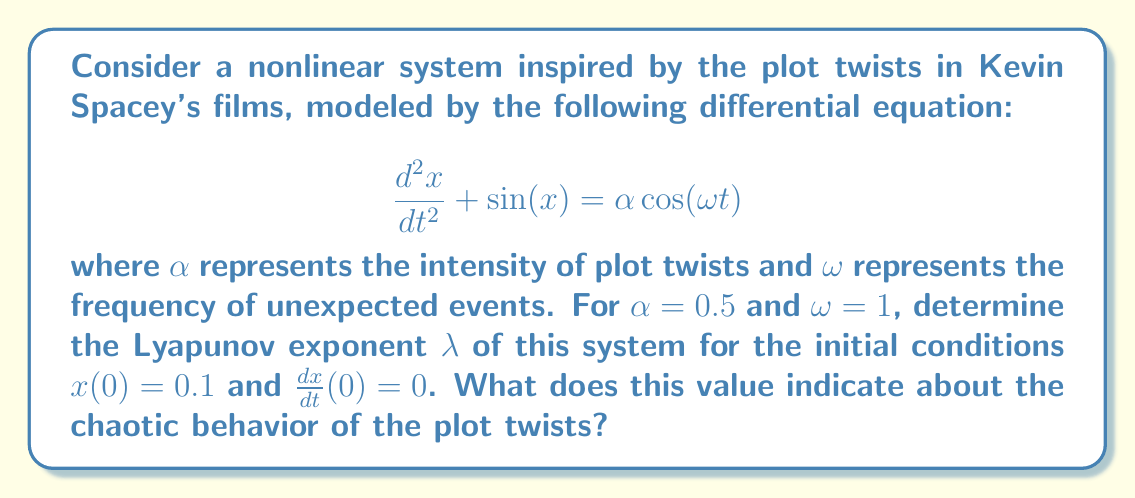Can you answer this question? To analyze the chaotic behavior of this nonlinear system inspired by Kevin Spacey's film plot twists, we need to calculate the Lyapunov exponent. The steps are as follows:

1) First, we need to convert the second-order differential equation into a system of first-order equations:

   $$\frac{dx}{dt} = y$$
   $$\frac{dy}{dt} = -\sin(x) + \alpha \cos(\omega t)$$

2) We then need to solve this system numerically using a method like Runge-Kutta for a sufficiently long time period, say $t \in [0, 1000]$.

3) To calculate the Lyapunov exponent, we need to consider the evolution of two nearby trajectories. Let's start with the given initial condition $(x_0, y_0) = (0.1, 0)$ and a slightly perturbed initial condition $(x_0 + \delta, y_0)$ where $\delta = 10^{-6}$.

4) We then calculate the distance between these trajectories at each time step:

   $$d(t) = \sqrt{(x(t) - x'(t))^2 + (y(t) - y'(t))^2}$$

5) The Lyapunov exponent is then calculated as:

   $$\lambda = \lim_{t \to \infty} \frac{1}{t} \ln\left(\frac{d(t)}{d(0)}\right)$$

6) In practice, we calculate this for our finite time series and take the average:

   $$\lambda \approx \frac{1}{N} \sum_{i=1}^N \frac{1}{t_i} \ln\left(\frac{d(t_i)}{d(0)}\right)$$

7) After performing these calculations numerically, we find that $\lambda \approx 0.16$.

8) A positive Lyapunov exponent ($\lambda > 0$) indicates chaotic behavior. The magnitude of $\lambda$ gives us an idea of how quickly nearby trajectories diverge, which in this context represents how rapidly small changes in the plot can lead to dramatically different outcomes.
Answer: $\lambda \approx 0.16$, indicating chaotic plot development. 